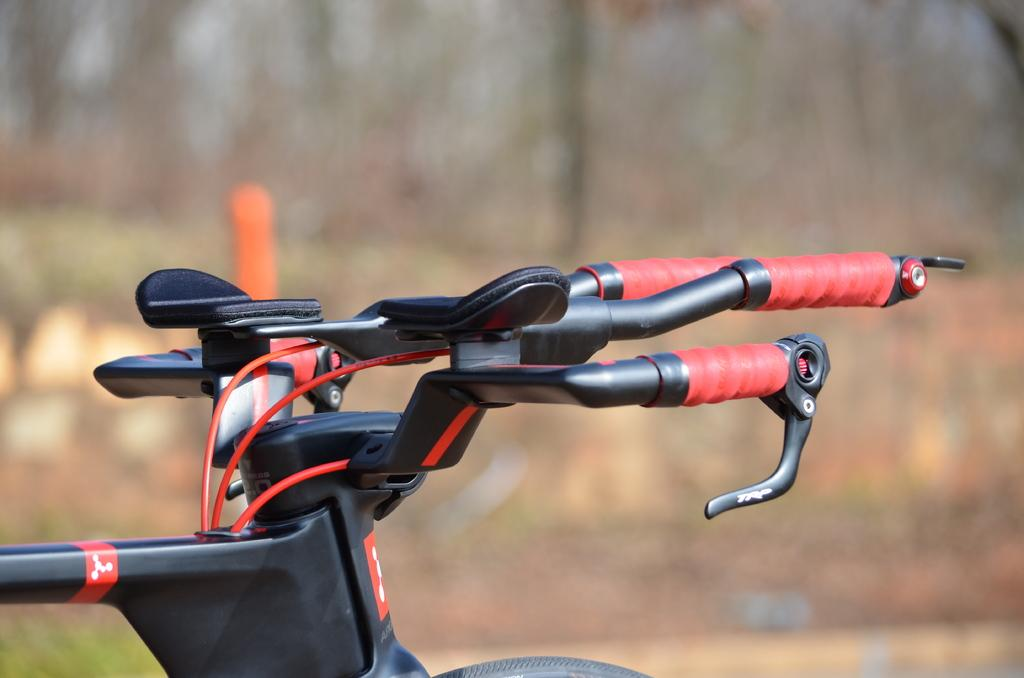What is the main object in the image? There is a bicycle in the image. What can be seen in the background of the image? There are trees and plants on the land in the background of the image. How much credit does the bicycle have in the image? There is no mention of credit or any financial aspect in the image; it simply shows a bicycle and the background. 